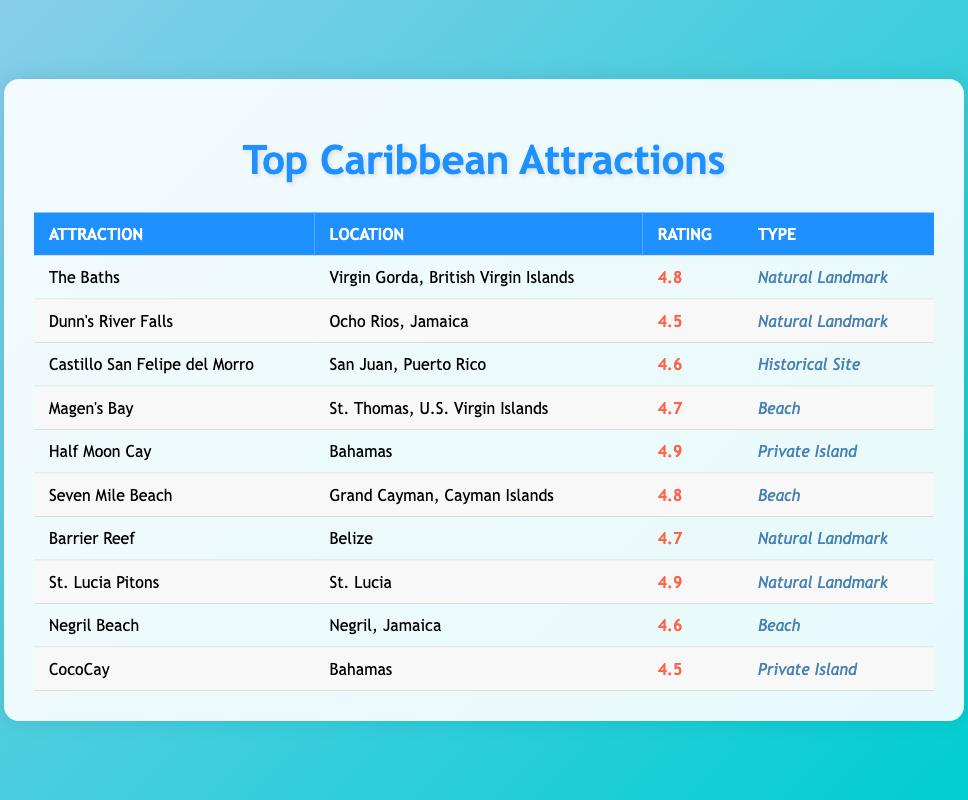What is the highest average visitor rating among the attractions listed? The table shows the average visitor ratings for each attraction. By scanning through the "Rating" column, I find that Half Moon Cay and St. Lucia Pitons both have the highest rating of 4.9, which is greater than the ratings of all other attractions listed.
Answer: 4.9 Which attraction is located in Jamaica? By looking through the "Location" column, I see that both Dunn's River Falls and Negril Beach are listed under Jamaica. They are the only attractions with Jamaica as their location.
Answer: Dunn's River Falls and Negril Beach How many attractions have an average visitor rating of 4.6 or higher? The average ratings listed in the "Rating" column are 4.8, 4.5, 4.6, 4.7, 4.9, 4.8, 4.7, 4.9, 4.6, and 4.5. Counting each rating that is 4.6 or above, I find there are 8 attractions with such ratings: The Baths, Castillo San Felipe del Morro, Magen's Bay, Half Moon Cay, Seven Mile Beach, Barrier Reef, St. Lucia Pitons, and Negril Beach.
Answer: 8 Is the average visitor rating of CocoCay higher than that of Dunn's River Falls? Checking the "Rating" column, I see that CocoCay has a rating of 4.5, while Dunn's River Falls has a rating of 4.5. Since both ratings are equal, CocoCay's rating is not higher than Dunn's River Falls's rating. Hence, the statement is false.
Answer: No What is the average rating of all attractions categorized as "Beach"? From the table, the attractions categorized as "Beach" are Magen's Bay (4.7), Seven Mile Beach (4.8), and Negril Beach (4.6). To find the average, I sum these ratings: 4.7 + 4.8 + 4.6 = 14.1. There are 3 attractions, so the average is 14.1 / 3 = 4.7.
Answer: 4.7 Which type of attraction has the most entries in the table? Upon examining the "Type" column, I identify the types of attractions listed: Natural Landmark (4 entries), Beach (3 entries), Historical Site (1 entry), and Private Island (2 entries). The type "Natural Landmark," with 4 entries, is the most common type in the table.
Answer: Natural Landmark 